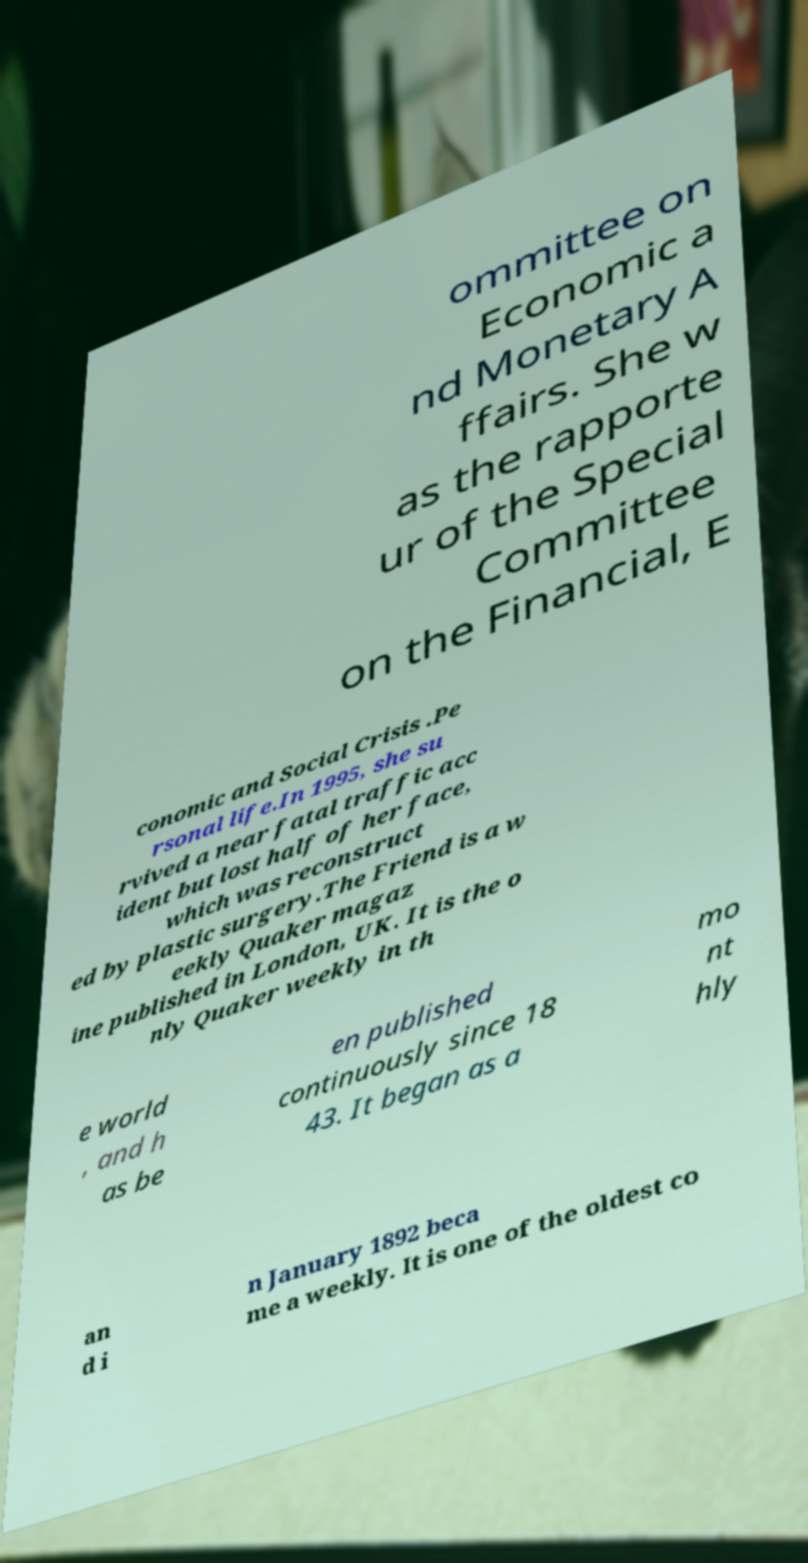Please identify and transcribe the text found in this image. ommittee on Economic a nd Monetary A ffairs. She w as the rapporte ur of the Special Committee on the Financial, E conomic and Social Crisis .Pe rsonal life.In 1995, she su rvived a near fatal traffic acc ident but lost half of her face, which was reconstruct ed by plastic surgery.The Friend is a w eekly Quaker magaz ine published in London, UK. It is the o nly Quaker weekly in th e world , and h as be en published continuously since 18 43. It began as a mo nt hly an d i n January 1892 beca me a weekly. It is one of the oldest co 